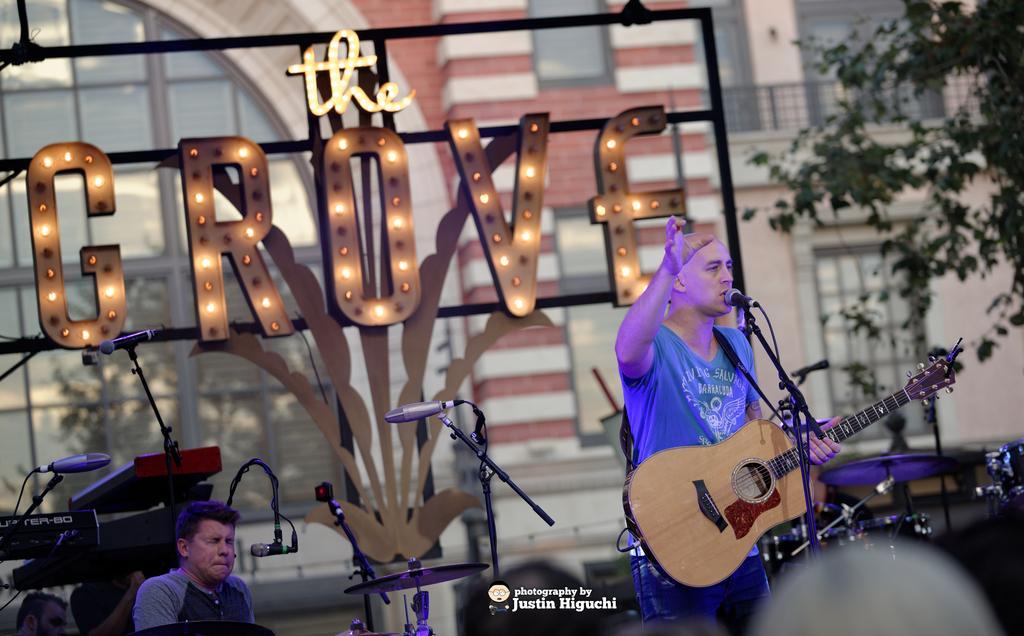How would you summarize this image in a sentence or two? In this image I can see a two person. In front the person is holding a guitar and there is a mic and a stand. At the back side there is a building and a tree. 